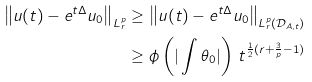<formula> <loc_0><loc_0><loc_500><loc_500>\left \| u ( t ) - e ^ { t \Delta } u _ { 0 } \right \| _ { L ^ { p } _ { r } } & \geq \left \| u ( t ) - e ^ { t \Delta } u _ { 0 } \right \| _ { L ^ { p } _ { r } ( \mathcal { D } _ { A , t } ) } \\ & \geq \phi \left ( | \int \theta _ { 0 } | \right ) \, t ^ { \frac { 1 } { 2 } ( r + \frac { 3 } { p } - 1 ) }</formula> 